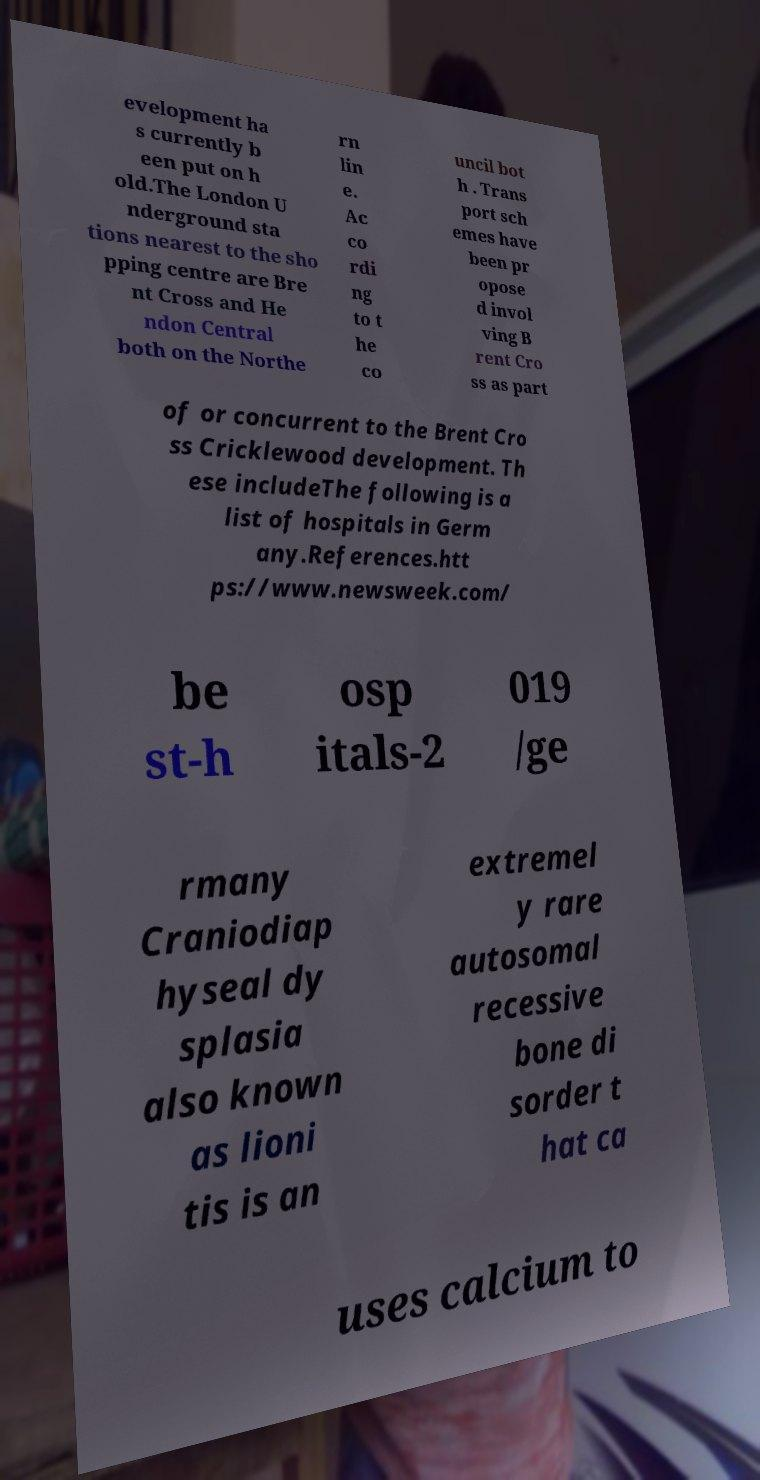For documentation purposes, I need the text within this image transcribed. Could you provide that? evelopment ha s currently b een put on h old.The London U nderground sta tions nearest to the sho pping centre are Bre nt Cross and He ndon Central both on the Northe rn lin e. Ac co rdi ng to t he co uncil bot h . Trans port sch emes have been pr opose d invol ving B rent Cro ss as part of or concurrent to the Brent Cro ss Cricklewood development. Th ese includeThe following is a list of hospitals in Germ any.References.htt ps://www.newsweek.com/ be st-h osp itals-2 019 /ge rmany Craniodiap hyseal dy splasia also known as lioni tis is an extremel y rare autosomal recessive bone di sorder t hat ca uses calcium to 